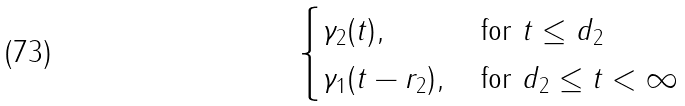<formula> <loc_0><loc_0><loc_500><loc_500>\begin{cases} \gamma _ { 2 } ( t ) , \, & \text {for $t\leq d_{2}$} \\ \gamma _ { 1 } ( t - r _ { 2 } ) , \, & \text {for $d_{2}\leq t<\infty$} \end{cases}</formula> 